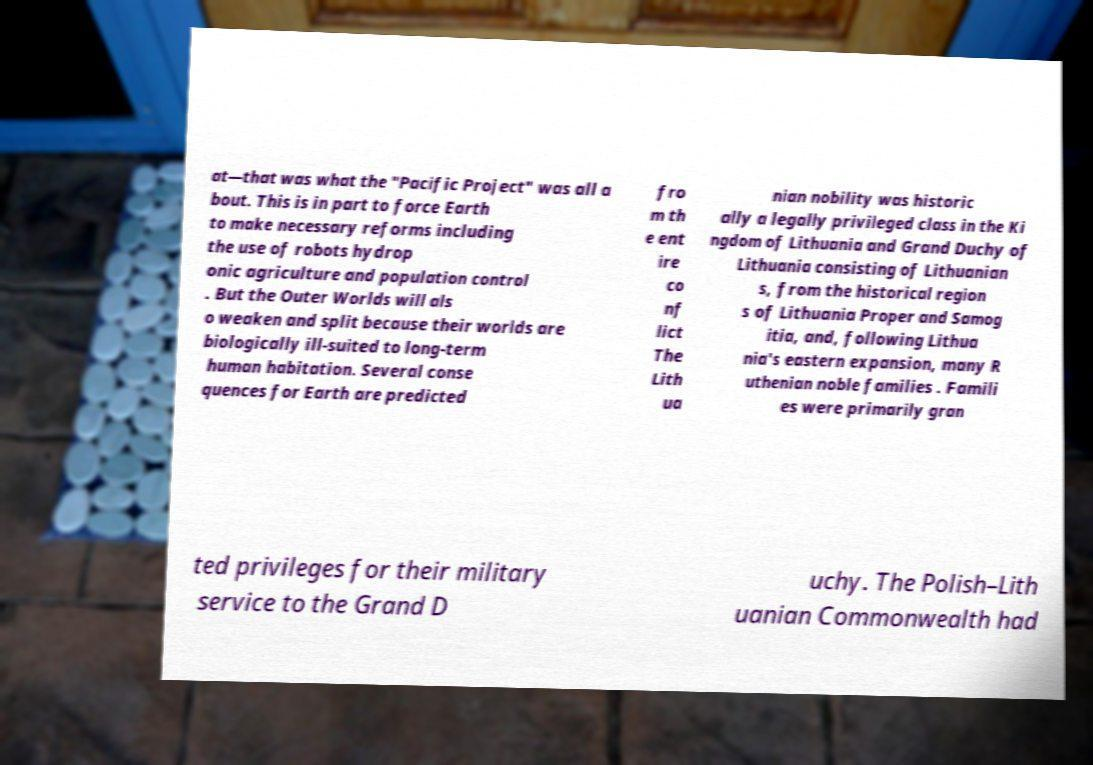Could you extract and type out the text from this image? at—that was what the "Pacific Project" was all a bout. This is in part to force Earth to make necessary reforms including the use of robots hydrop onic agriculture and population control . But the Outer Worlds will als o weaken and split because their worlds are biologically ill-suited to long-term human habitation. Several conse quences for Earth are predicted fro m th e ent ire co nf lict The Lith ua nian nobility was historic ally a legally privileged class in the Ki ngdom of Lithuania and Grand Duchy of Lithuania consisting of Lithuanian s, from the historical region s of Lithuania Proper and Samog itia, and, following Lithua nia's eastern expansion, many R uthenian noble families . Famili es were primarily gran ted privileges for their military service to the Grand D uchy. The Polish–Lith uanian Commonwealth had 